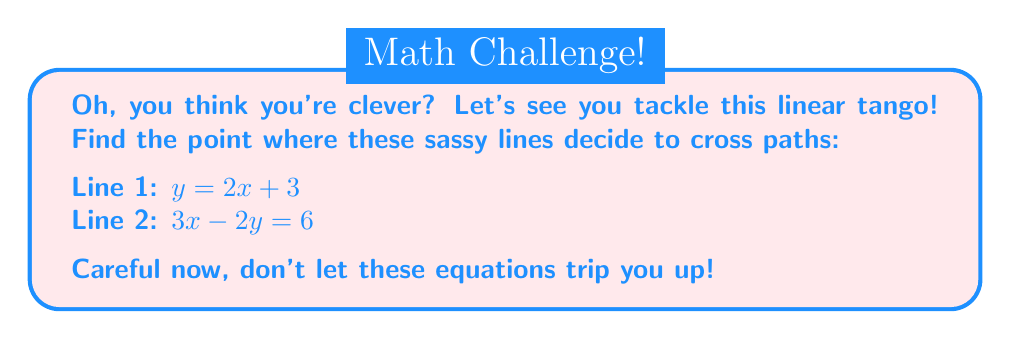What is the answer to this math problem? Alright, smartypants, let's waltz through this:

1) We've got two equations, and we need to make them play nice. Let's start by getting Line 2 into slope-intercept form:

   $3x - 2y = 6$
   $-2y = -3x + 6$
   $y = \frac{3x}{2} - 3$

2) Now we've got:
   Line 1: $y = 2x + 3$
   Line 2: $y = \frac{3x}{2} - 3$

3) At the intersection point, these y-values are equal. So let's set them equal and solve for x:

   $2x + 3 = \frac{3x}{2} - 3$

4) Time to show off those algebra moves:

   $2x + 6 = \frac{3x}{2}$
   $4x + 12 = 3x$
   $x + 12 = 0$
   $x = -12$

5) Now that we've cornered x, let's find y by plugging x back into either equation. Let's use Line 1 because it looks friendlier:

   $y = 2(-12) + 3 = -24 + 3 = -21$

6) Ta-da! We've got our intersection point: $(-12, -21)$. 

Who's sassy now, equations?
Answer: $(-12, -21)$ 